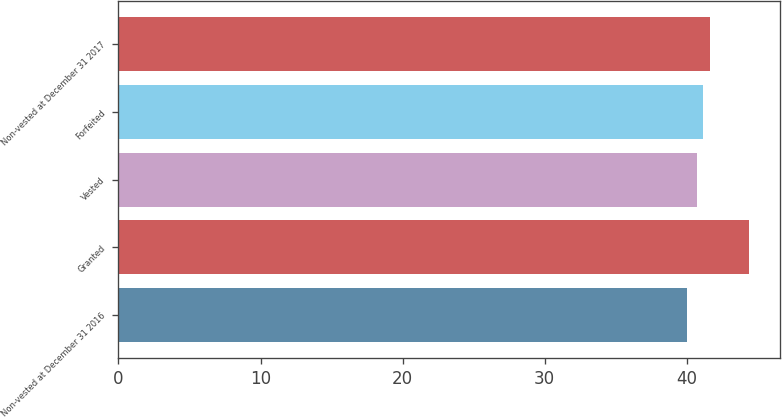Convert chart to OTSL. <chart><loc_0><loc_0><loc_500><loc_500><bar_chart><fcel>Non-vested at December 31 2016<fcel>Granted<fcel>Vested<fcel>Forfeited<fcel>Non-vested at December 31 2017<nl><fcel>40.03<fcel>44.38<fcel>40.74<fcel>41.18<fcel>41.62<nl></chart> 